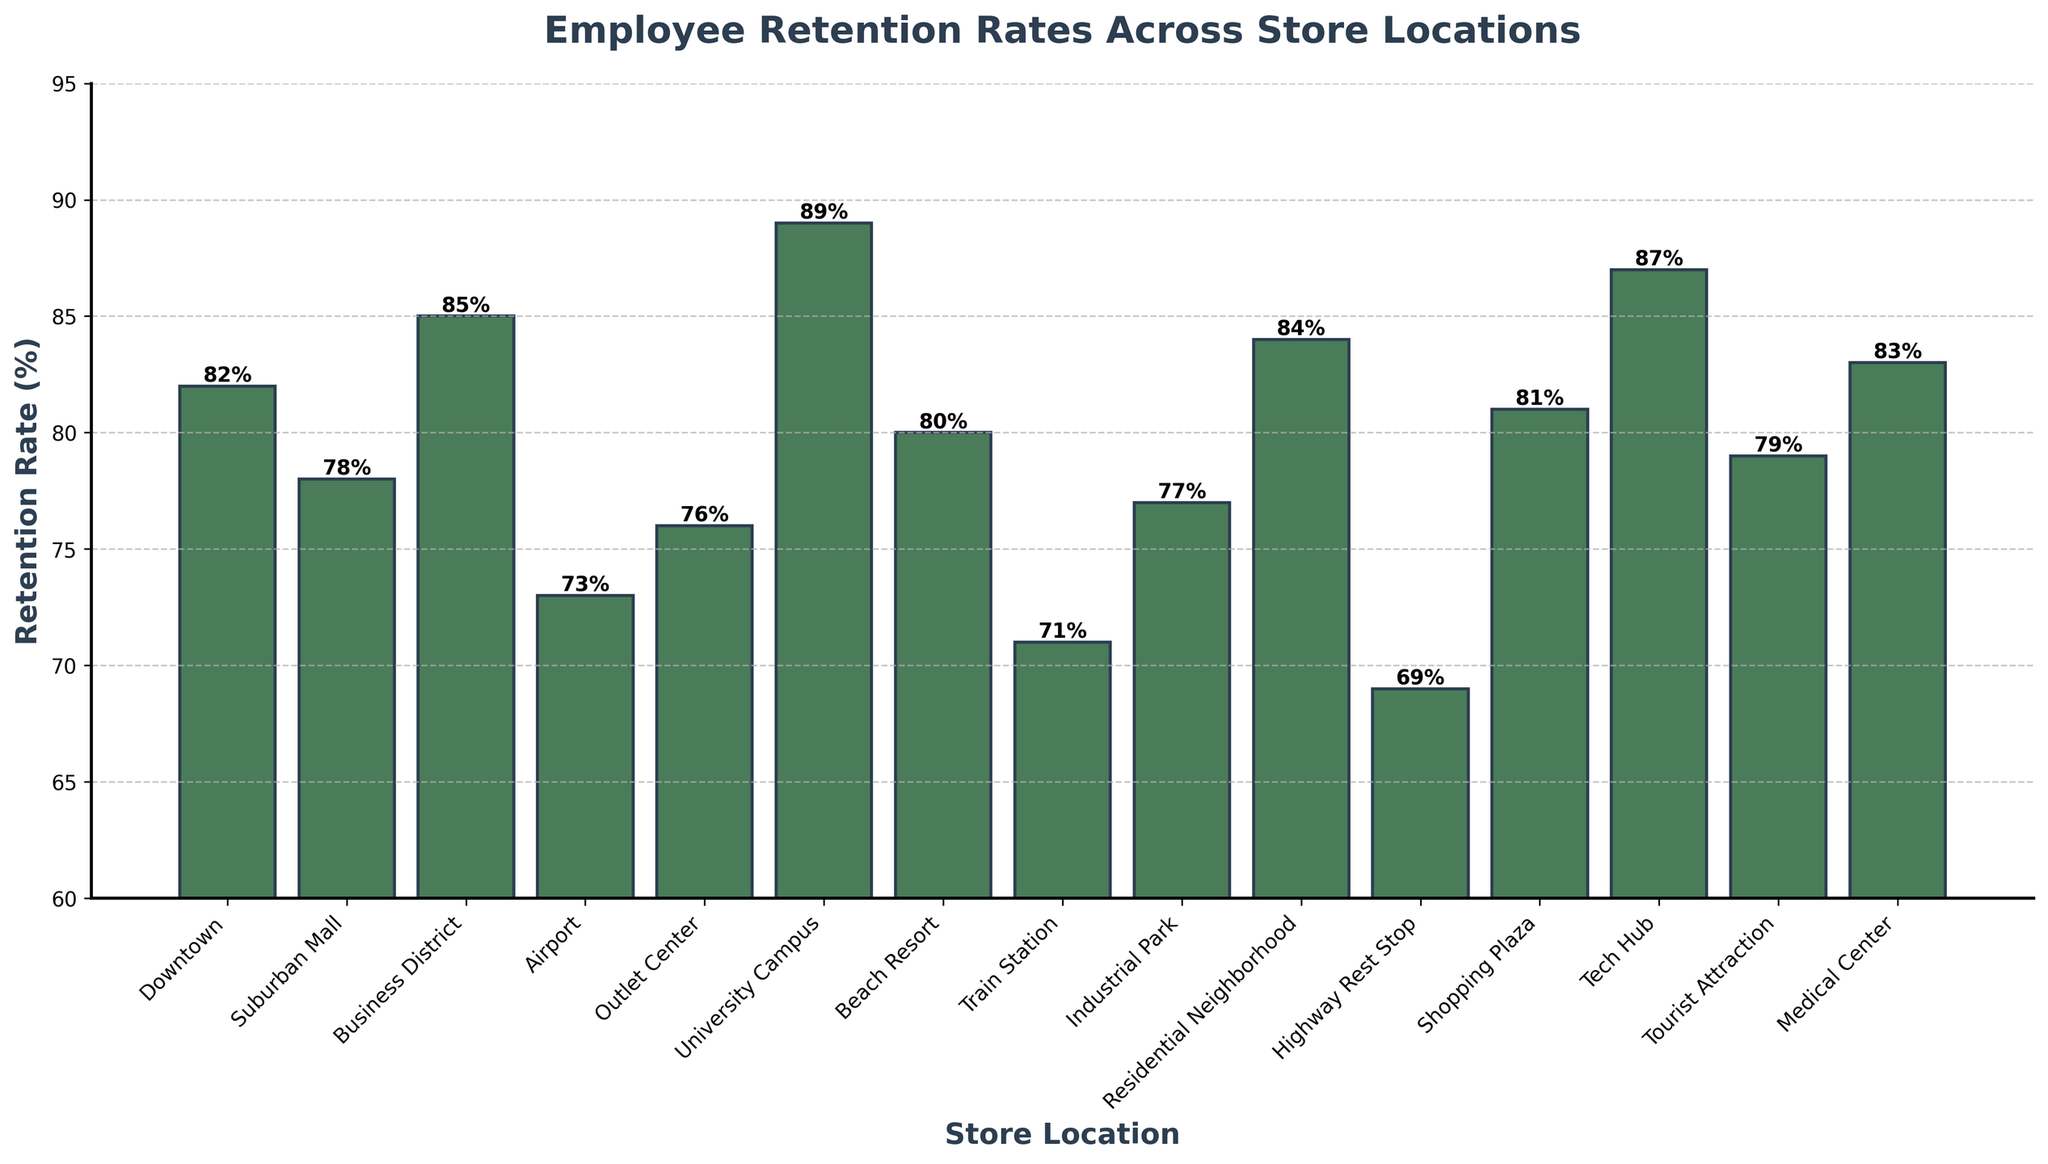What's the retention rate at the University Campus? The University Campus retention rate is shown as a bar on the chart. By visually checking the height of the bar and confirming the label, the rate is 89%.
Answer: 89% Which store location has the lowest employee retention rate? The lowest retention rate can be found by identifying the shortest bar on the chart, which corresponds to the Highway Rest Stop.
Answer: Highway Rest Stop How much higher is the retention rate at the University Campus compared to the Suburban Mall? The retention rate at the University Campus is 89%, and at the Suburban Mall it is 78%. Subtracting these gives 89% - 78% = 11%.
Answer: 11% What is the average employee retention rate across all store locations? Sum all the retention rates: 82 + 78 + 85 + 73 + 76 + 89 + 80 + 71 + 77 + 84 + 69 + 81 + 87 + 79 + 83 = 1144. There are 15 locations, so the average is 1144 / 15 ≈ 76.27%.
Answer: 76.27% Which store location has a higher retention rate: Business District or Tech Hub? Comparing the heights of the bars for Business District (85%) and Tech Hub (87%), the Tech Hub has a higher retention rate.
Answer: Tech Hub What is the range of retention rates across all store locations? The range is found by subtracting the smallest retention rate (Highway Rest Stop, 69%) from the largest (University Campus, 89%). Thus, 89% - 69% = 20%.
Answer: 20% How many store locations have a retention rate greater than 80%? Count the number of bars with heights above 80%. The locations are: Downtown, Business District, University Campus, Residential Neighborhood, Shopping Plaza, Tech Hub, and Medical Center, totaling 7 locations.
Answer: 7 What is the median retention rate across the store locations? To find the median, first list the retention rates in ascending order: 69, 71, 73, 76, 77, 78, 79, 80, 81, 82, 83, 84, 85, 87, 89. The median is the middle value, the 8th number: 80%.
Answer: 80% Which store locations have retention rates less than or equal to 75%? Identify bars with heights ≤75%. The locations are Airport (73%), Highway Rest Stop (69%), and Train Station (71%).
Answer: Airport, Highway Rest Stop, Train Station 